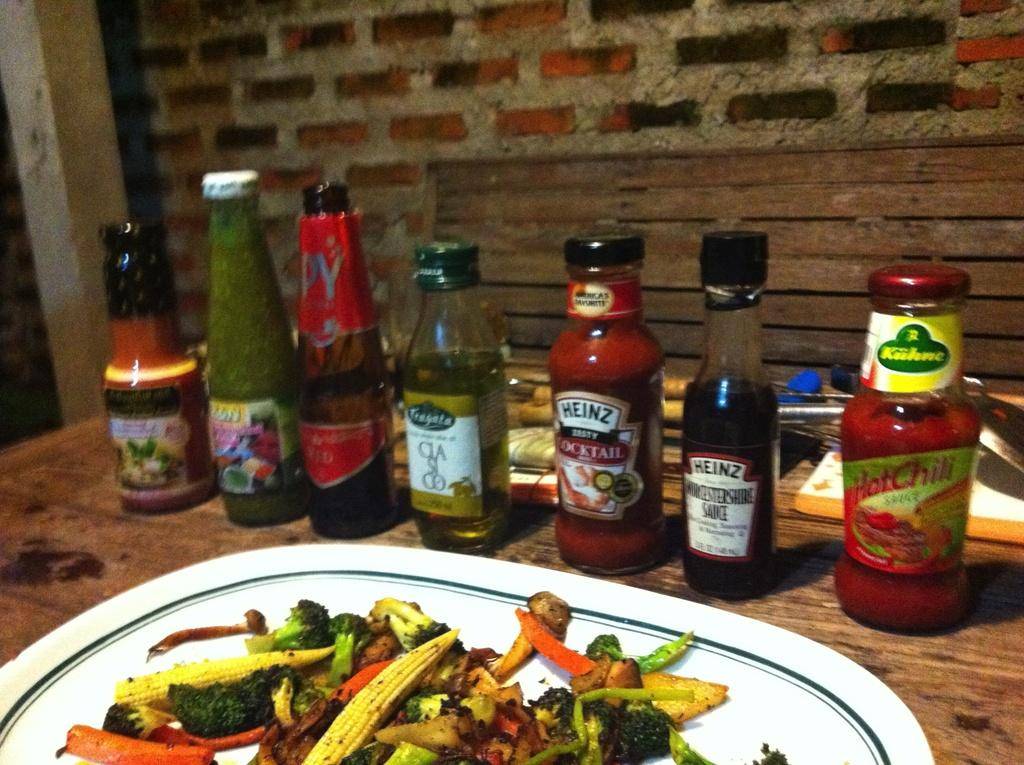What objects are visible in the image? There are bottles and a plate with food in the image. Where are the plate and bottles located? The plate and bottles are on a table. What type of roof can be seen in the image? There is no roof visible in the image; it only shows bottles and a plate with food on a table. 